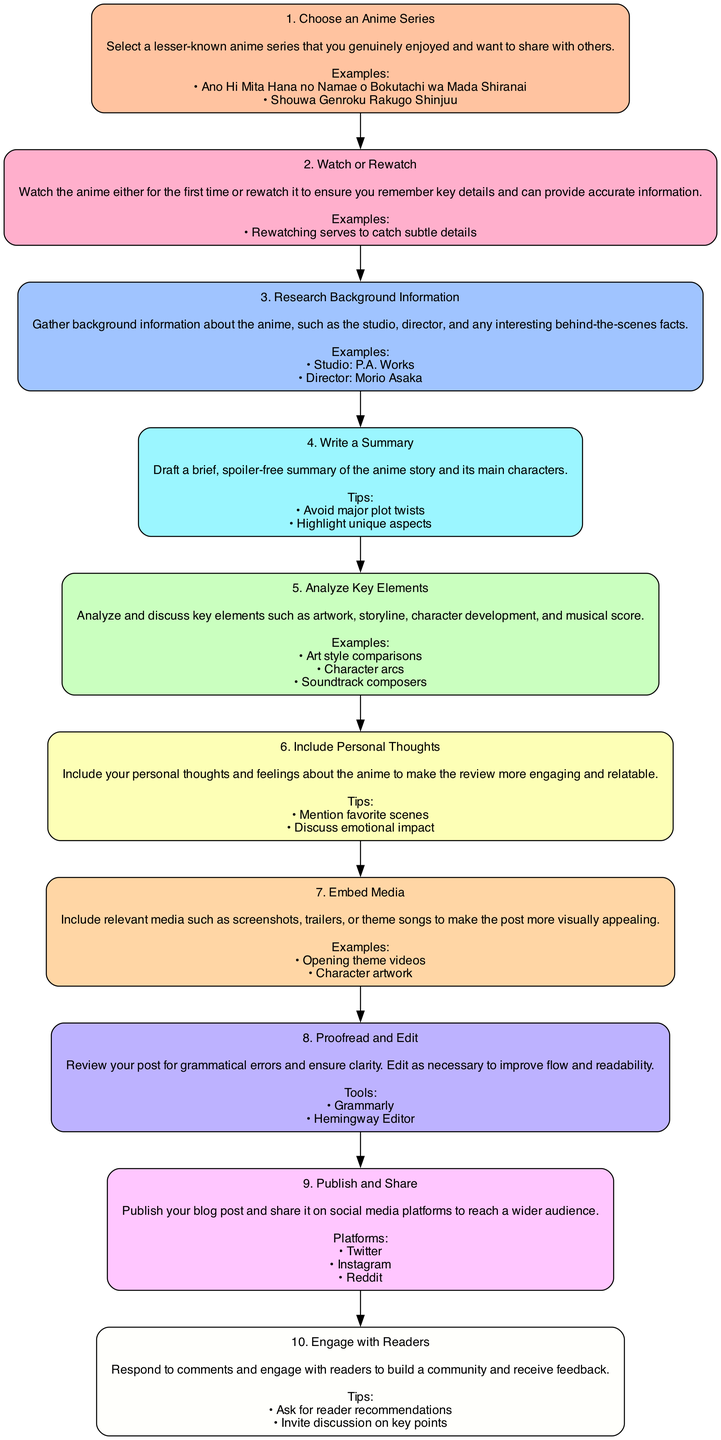What is the first step in creating an engaging anime review blog post? The first step, shown at the top of the flowchart, is "Choose an Anime Series". This is the initiation of the process where one selects a series to review.
Answer: Choose an Anime Series How many steps are there in total in the diagram? By counting the number of different nodes displayed in the flowchart, we find there are a total of 10 distinct steps outlined.
Answer: 10 What should you do after "Write a Summary"? Following "Write a Summary", the next step in the flowchart is "Analyze Key Elements". This indicates the process of examining various aspects of the anime comes after summarizing the story.
Answer: Analyze Key Elements What tools are suggested for proofreading and editing? The flowchart specifies "Grammarly" and "Hemingway Editor" as recommended tools for proofreading and editing your review to ensure quality.
Answer: Grammarly, Hemingway Editor Which step includes personal thoughts and feelings? The step dedicated to personal insights is "Include Personal Thoughts". It emphasizes the importance of sharing personal reflections to enhance reader engagement.
Answer: Include Personal Thoughts What is the last step in the process? The last step in the flowchart is "Engage with Readers", which focuses on building community after publishing the blog post.
Answer: Engage with Readers Which step involves gathering background information? The step pertaining to background information is "Research Background Information". This step is important for collecting context about the anime being reviewed.
Answer: Research Background Information How many examples are provided for "Embed Media"? The diagram lists two examples related to the "Embed Media" step: "Opening theme videos" and "Character artwork". This means there are two examples mentioned in that section.
Answer: 2 What platform is NOT listed for sharing the blog post? The flowchart lists "Twitter", "Instagram", and "Reddit" as platforms for sharing the post, but it does not include "Facebook", which is absent in the diagram.
Answer: Facebook 